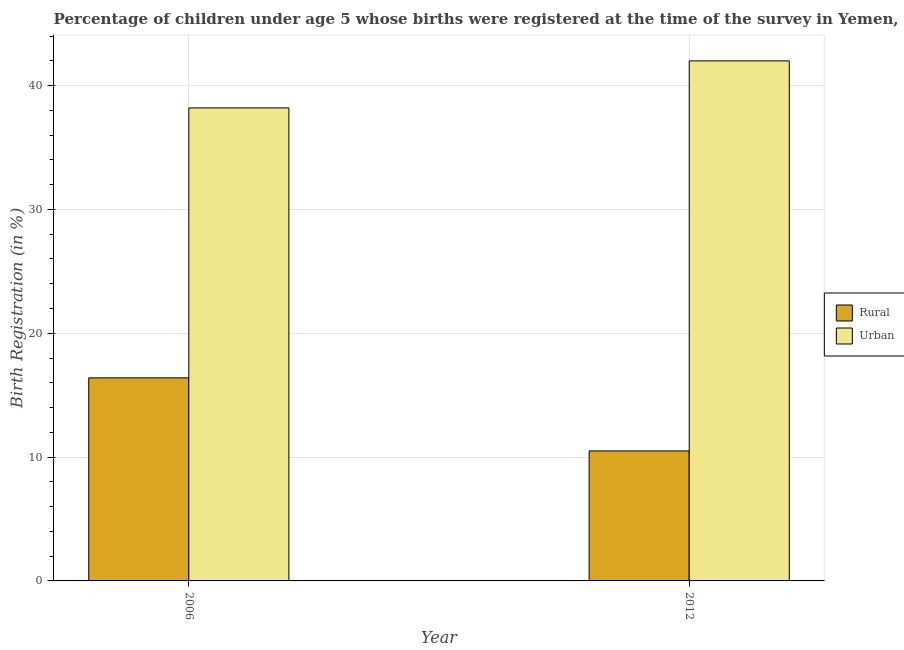How many different coloured bars are there?
Keep it short and to the point. 2. How many bars are there on the 2nd tick from the left?
Ensure brevity in your answer.  2. How many bars are there on the 2nd tick from the right?
Your answer should be very brief. 2. What is the label of the 2nd group of bars from the left?
Give a very brief answer. 2012. Across all years, what is the minimum urban birth registration?
Provide a succinct answer. 38.2. In which year was the urban birth registration maximum?
Give a very brief answer. 2012. What is the total rural birth registration in the graph?
Provide a succinct answer. 26.9. What is the difference between the urban birth registration in 2006 and that in 2012?
Give a very brief answer. -3.8. What is the difference between the urban birth registration in 2012 and the rural birth registration in 2006?
Ensure brevity in your answer.  3.8. What is the average urban birth registration per year?
Give a very brief answer. 40.1. What is the ratio of the urban birth registration in 2006 to that in 2012?
Your answer should be compact. 0.91. Is the rural birth registration in 2006 less than that in 2012?
Your answer should be compact. No. In how many years, is the urban birth registration greater than the average urban birth registration taken over all years?
Ensure brevity in your answer.  1. What does the 1st bar from the left in 2012 represents?
Ensure brevity in your answer.  Rural. What does the 2nd bar from the right in 2012 represents?
Offer a very short reply. Rural. How many bars are there?
Make the answer very short. 4. Are all the bars in the graph horizontal?
Provide a short and direct response. No. How many years are there in the graph?
Offer a very short reply. 2. What is the difference between two consecutive major ticks on the Y-axis?
Your answer should be compact. 10. Are the values on the major ticks of Y-axis written in scientific E-notation?
Make the answer very short. No. What is the title of the graph?
Your answer should be very brief. Percentage of children under age 5 whose births were registered at the time of the survey in Yemen, Rep. What is the label or title of the X-axis?
Ensure brevity in your answer.  Year. What is the label or title of the Y-axis?
Provide a succinct answer. Birth Registration (in %). What is the Birth Registration (in %) of Rural in 2006?
Your response must be concise. 16.4. What is the Birth Registration (in %) of Urban in 2006?
Ensure brevity in your answer.  38.2. Across all years, what is the maximum Birth Registration (in %) in Rural?
Give a very brief answer. 16.4. Across all years, what is the minimum Birth Registration (in %) in Urban?
Offer a terse response. 38.2. What is the total Birth Registration (in %) of Rural in the graph?
Offer a terse response. 26.9. What is the total Birth Registration (in %) in Urban in the graph?
Make the answer very short. 80.2. What is the difference between the Birth Registration (in %) in Urban in 2006 and that in 2012?
Offer a terse response. -3.8. What is the difference between the Birth Registration (in %) of Rural in 2006 and the Birth Registration (in %) of Urban in 2012?
Ensure brevity in your answer.  -25.6. What is the average Birth Registration (in %) of Rural per year?
Your answer should be very brief. 13.45. What is the average Birth Registration (in %) in Urban per year?
Offer a terse response. 40.1. In the year 2006, what is the difference between the Birth Registration (in %) in Rural and Birth Registration (in %) in Urban?
Your answer should be compact. -21.8. In the year 2012, what is the difference between the Birth Registration (in %) in Rural and Birth Registration (in %) in Urban?
Provide a short and direct response. -31.5. What is the ratio of the Birth Registration (in %) in Rural in 2006 to that in 2012?
Keep it short and to the point. 1.56. What is the ratio of the Birth Registration (in %) of Urban in 2006 to that in 2012?
Provide a short and direct response. 0.91. What is the difference between the highest and the lowest Birth Registration (in %) of Urban?
Your answer should be very brief. 3.8. 